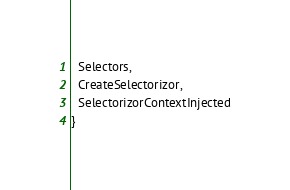<code> <loc_0><loc_0><loc_500><loc_500><_TypeScript_>  Selectors,
  CreateSelectorizor,
  SelectorizorContextInjected
}</code> 